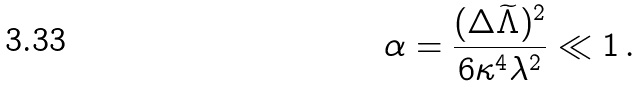<formula> <loc_0><loc_0><loc_500><loc_500>\alpha = { \frac { ( \Delta \widetilde { \Lambda } ) ^ { 2 } } { 6 \kappa ^ { 4 } \lambda ^ { 2 } } } \ll 1 \, .</formula> 